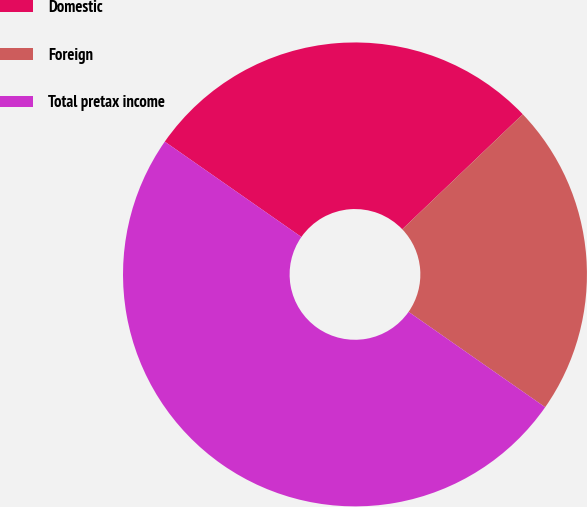Convert chart to OTSL. <chart><loc_0><loc_0><loc_500><loc_500><pie_chart><fcel>Domestic<fcel>Foreign<fcel>Total pretax income<nl><fcel>28.17%<fcel>21.83%<fcel>50.0%<nl></chart> 